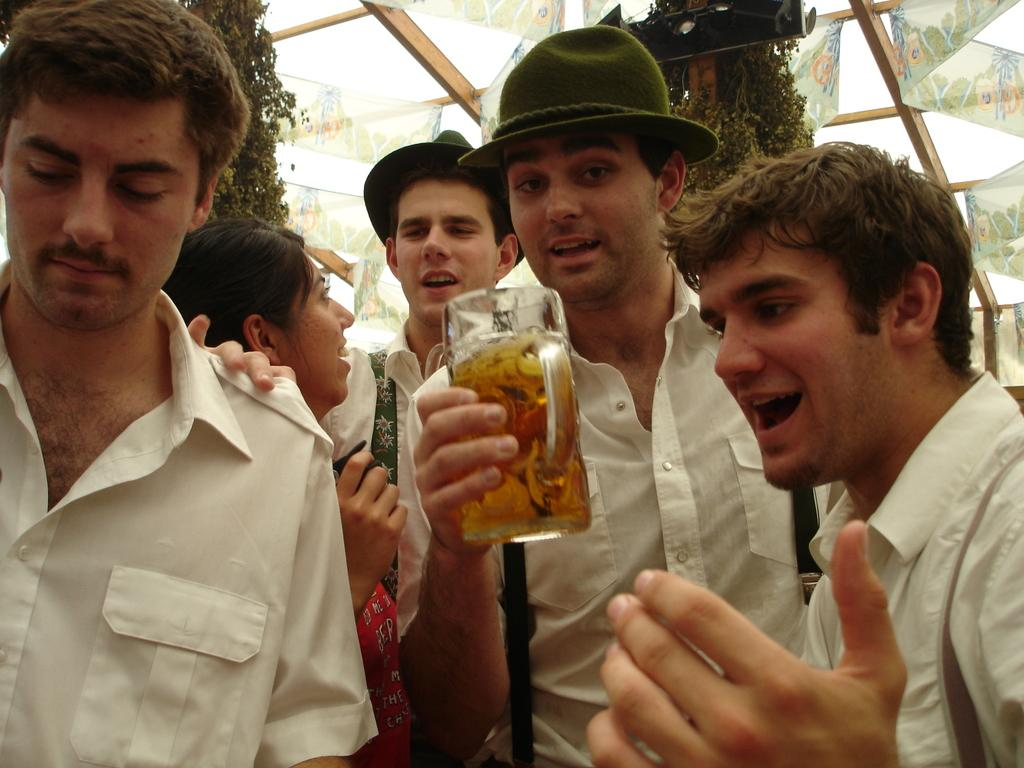How many people are in the image? There is a group of people in the image, but the exact number is not specified. Can you describe the person in the center of the group? The person in the center of the group is wearing a white shirt and holding a glass. What can be seen in the background of the image? There are trees, wooden sticks, and a ladder in the background of the image. What color is the eye of the person with a white shirt in the image? There is no mention of a person's eye color in the provided facts, and therefore it cannot be determined from the image. 